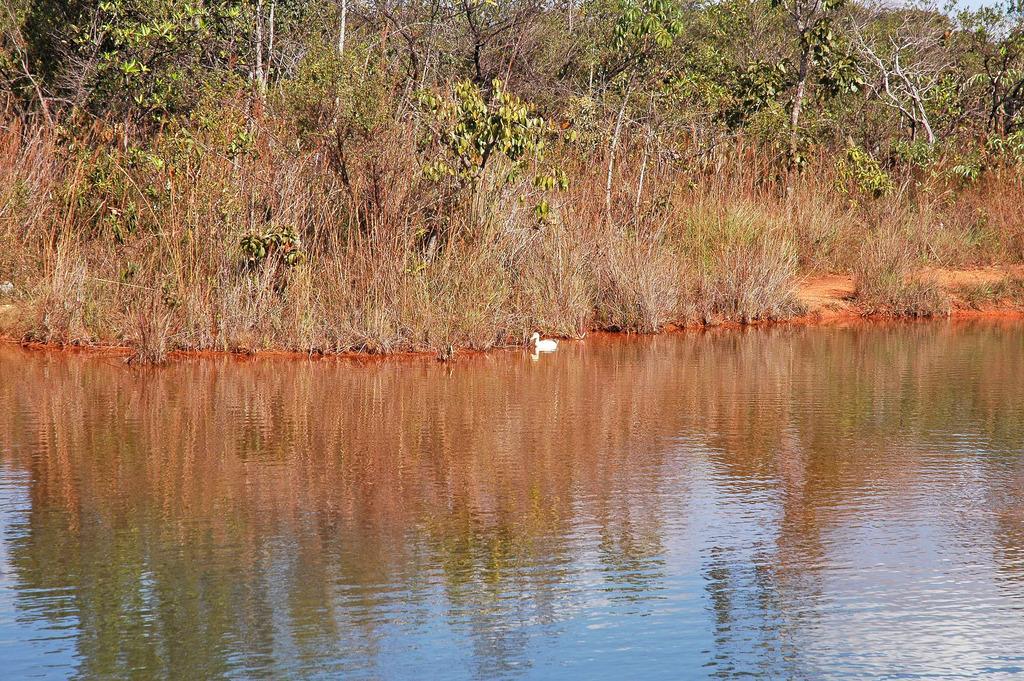Describe this image in one or two sentences. In this picture I can see the water in front and I can see a white color bird in the center of this picture and it is on the water. In the background I can see the plants and the trees. 